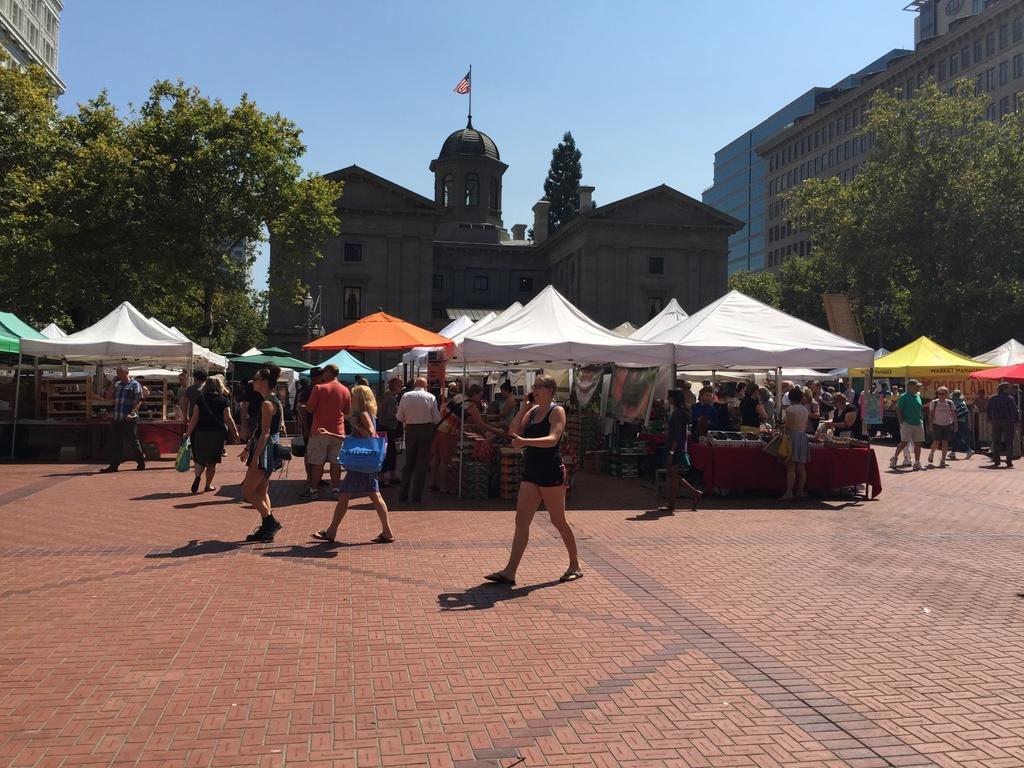Can you describe this image briefly? In the picture I can see people walking on the road, I can see tents, stalls, I can see buildings, trees and the plain blue color sky in the background. 